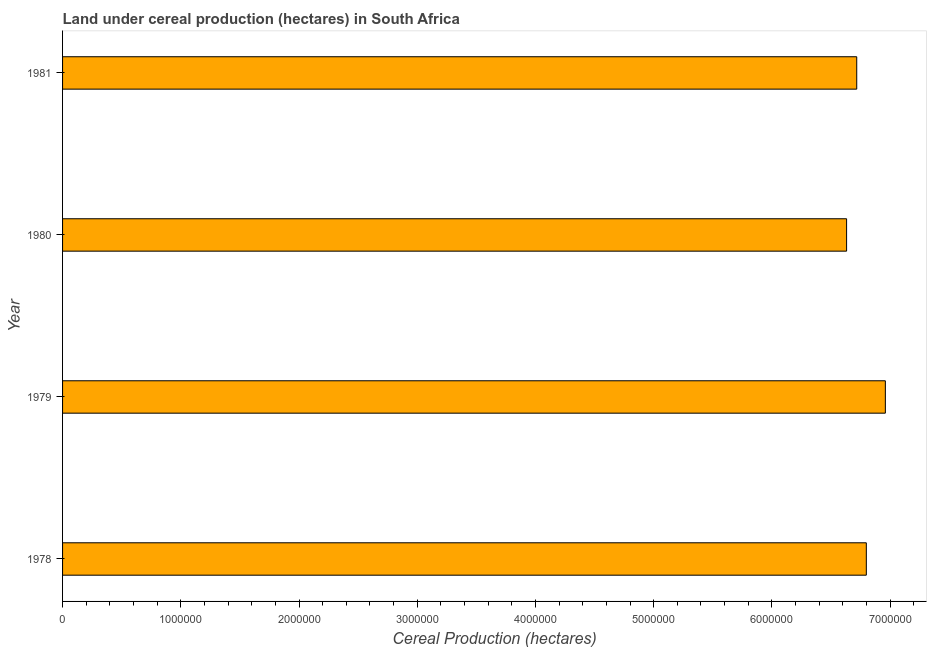Does the graph contain grids?
Make the answer very short. No. What is the title of the graph?
Give a very brief answer. Land under cereal production (hectares) in South Africa. What is the label or title of the X-axis?
Provide a succinct answer. Cereal Production (hectares). What is the label or title of the Y-axis?
Give a very brief answer. Year. What is the land under cereal production in 1978?
Keep it short and to the point. 6.80e+06. Across all years, what is the maximum land under cereal production?
Provide a succinct answer. 6.96e+06. Across all years, what is the minimum land under cereal production?
Provide a short and direct response. 6.63e+06. In which year was the land under cereal production maximum?
Give a very brief answer. 1979. What is the sum of the land under cereal production?
Your response must be concise. 2.71e+07. What is the difference between the land under cereal production in 1978 and 1979?
Provide a succinct answer. -1.61e+05. What is the average land under cereal production per year?
Give a very brief answer. 6.78e+06. What is the median land under cereal production?
Offer a very short reply. 6.76e+06. In how many years, is the land under cereal production greater than 5800000 hectares?
Offer a terse response. 4. Do a majority of the years between 1979 and 1978 (inclusive) have land under cereal production greater than 6400000 hectares?
Ensure brevity in your answer.  No. What is the difference between the highest and the second highest land under cereal production?
Your response must be concise. 1.61e+05. What is the difference between the highest and the lowest land under cereal production?
Your answer should be compact. 3.28e+05. How many bars are there?
Provide a short and direct response. 4. What is the Cereal Production (hectares) of 1978?
Keep it short and to the point. 6.80e+06. What is the Cereal Production (hectares) of 1979?
Provide a short and direct response. 6.96e+06. What is the Cereal Production (hectares) of 1980?
Your answer should be very brief. 6.63e+06. What is the Cereal Production (hectares) of 1981?
Ensure brevity in your answer.  6.72e+06. What is the difference between the Cereal Production (hectares) in 1978 and 1979?
Keep it short and to the point. -1.61e+05. What is the difference between the Cereal Production (hectares) in 1978 and 1980?
Make the answer very short. 1.67e+05. What is the difference between the Cereal Production (hectares) in 1978 and 1981?
Provide a succinct answer. 8.11e+04. What is the difference between the Cereal Production (hectares) in 1979 and 1980?
Offer a terse response. 3.28e+05. What is the difference between the Cereal Production (hectares) in 1979 and 1981?
Provide a short and direct response. 2.42e+05. What is the difference between the Cereal Production (hectares) in 1980 and 1981?
Provide a short and direct response. -8.59e+04. What is the ratio of the Cereal Production (hectares) in 1978 to that in 1980?
Provide a succinct answer. 1.02. What is the ratio of the Cereal Production (hectares) in 1978 to that in 1981?
Provide a succinct answer. 1.01. What is the ratio of the Cereal Production (hectares) in 1979 to that in 1980?
Keep it short and to the point. 1.05. What is the ratio of the Cereal Production (hectares) in 1979 to that in 1981?
Give a very brief answer. 1.04. What is the ratio of the Cereal Production (hectares) in 1980 to that in 1981?
Make the answer very short. 0.99. 